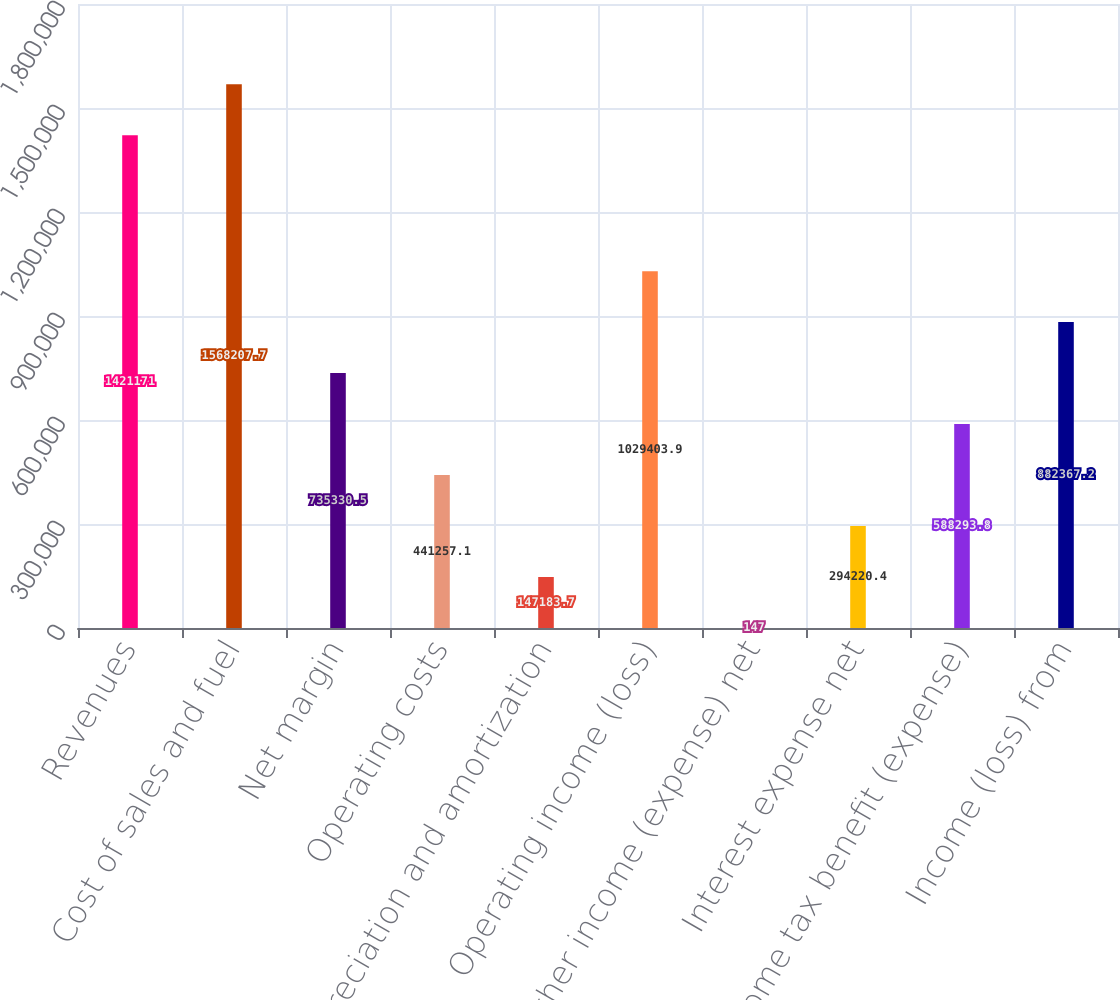<chart> <loc_0><loc_0><loc_500><loc_500><bar_chart><fcel>Revenues<fcel>Cost of sales and fuel<fcel>Net margin<fcel>Operating costs<fcel>Depreciation and amortization<fcel>Operating income (loss)<fcel>Other income (expense) net<fcel>Interest expense net<fcel>Income tax benefit (expense)<fcel>Income (loss) from<nl><fcel>1.42117e+06<fcel>1.56821e+06<fcel>735330<fcel>441257<fcel>147184<fcel>1.0294e+06<fcel>147<fcel>294220<fcel>588294<fcel>882367<nl></chart> 